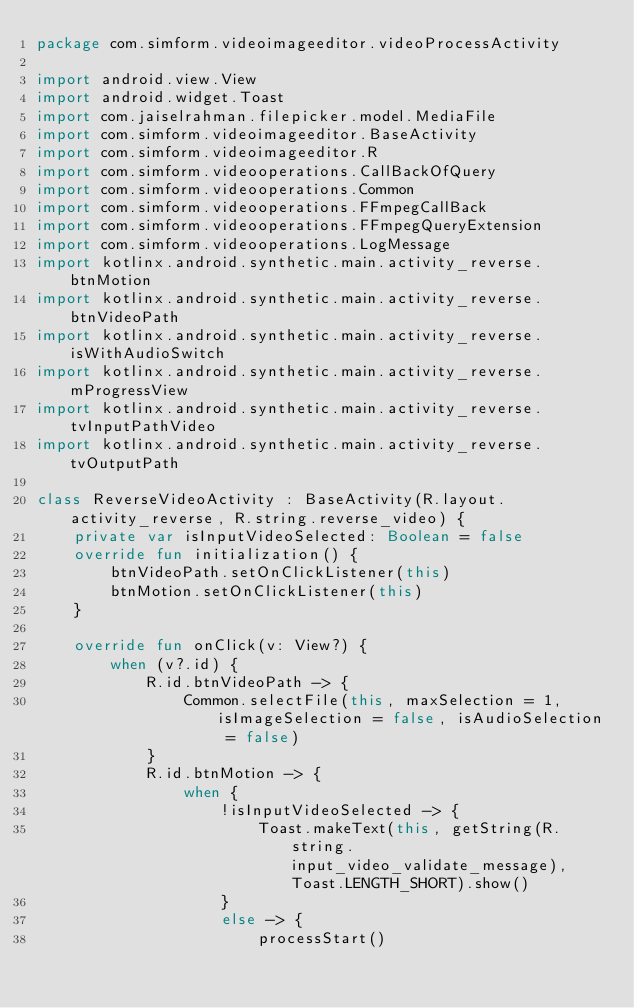<code> <loc_0><loc_0><loc_500><loc_500><_Kotlin_>package com.simform.videoimageeditor.videoProcessActivity

import android.view.View
import android.widget.Toast
import com.jaiselrahman.filepicker.model.MediaFile
import com.simform.videoimageeditor.BaseActivity
import com.simform.videoimageeditor.R
import com.simform.videooperations.CallBackOfQuery
import com.simform.videooperations.Common
import com.simform.videooperations.FFmpegCallBack
import com.simform.videooperations.FFmpegQueryExtension
import com.simform.videooperations.LogMessage
import kotlinx.android.synthetic.main.activity_reverse.btnMotion
import kotlinx.android.synthetic.main.activity_reverse.btnVideoPath
import kotlinx.android.synthetic.main.activity_reverse.isWithAudioSwitch
import kotlinx.android.synthetic.main.activity_reverse.mProgressView
import kotlinx.android.synthetic.main.activity_reverse.tvInputPathVideo
import kotlinx.android.synthetic.main.activity_reverse.tvOutputPath

class ReverseVideoActivity : BaseActivity(R.layout.activity_reverse, R.string.reverse_video) {
    private var isInputVideoSelected: Boolean = false
    override fun initialization() {
        btnVideoPath.setOnClickListener(this)
        btnMotion.setOnClickListener(this)
    }

    override fun onClick(v: View?) {
        when (v?.id) {
            R.id.btnVideoPath -> {
                Common.selectFile(this, maxSelection = 1, isImageSelection = false, isAudioSelection = false)
            }
            R.id.btnMotion -> {
                when {
                    !isInputVideoSelected -> {
                        Toast.makeText(this, getString(R.string.input_video_validate_message), Toast.LENGTH_SHORT).show()
                    }
                    else -> {
                        processStart()</code> 